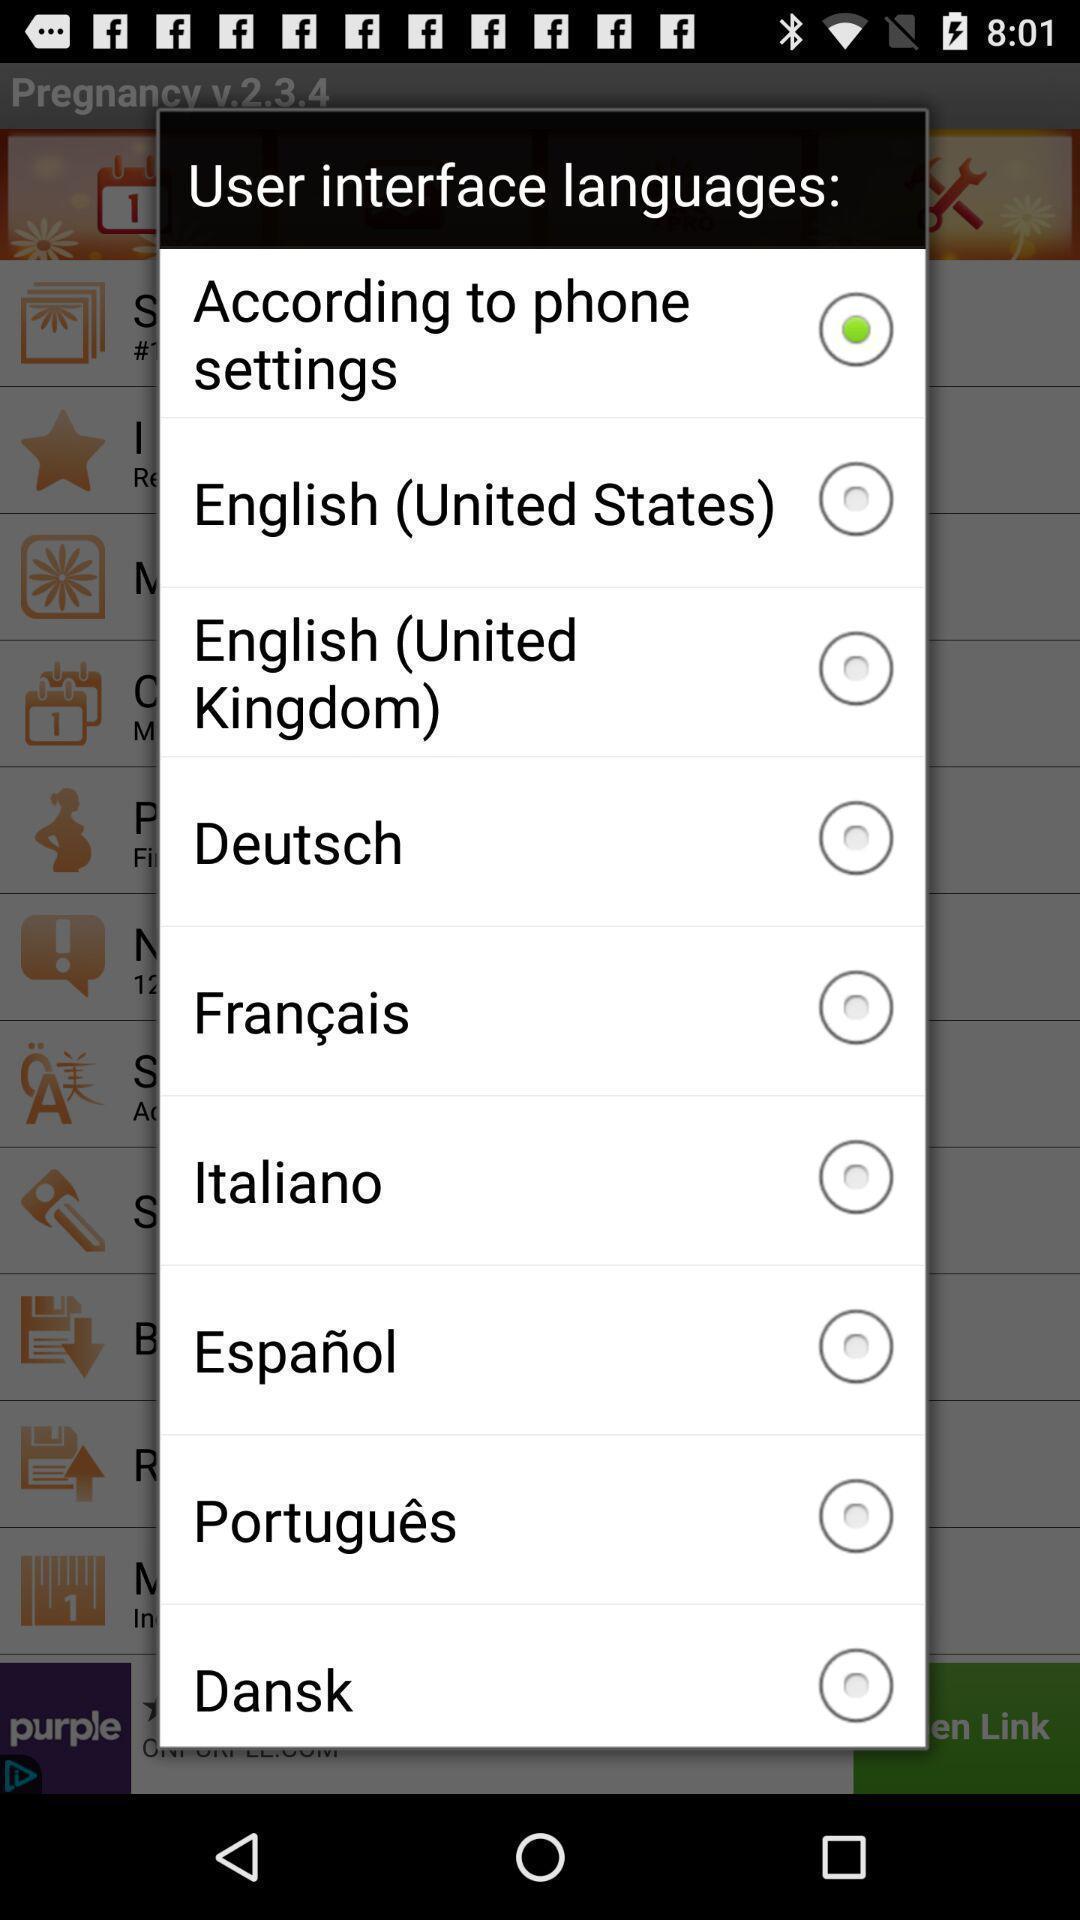Explain the elements present in this screenshot. Popup page for choosing user interface language for an app. 